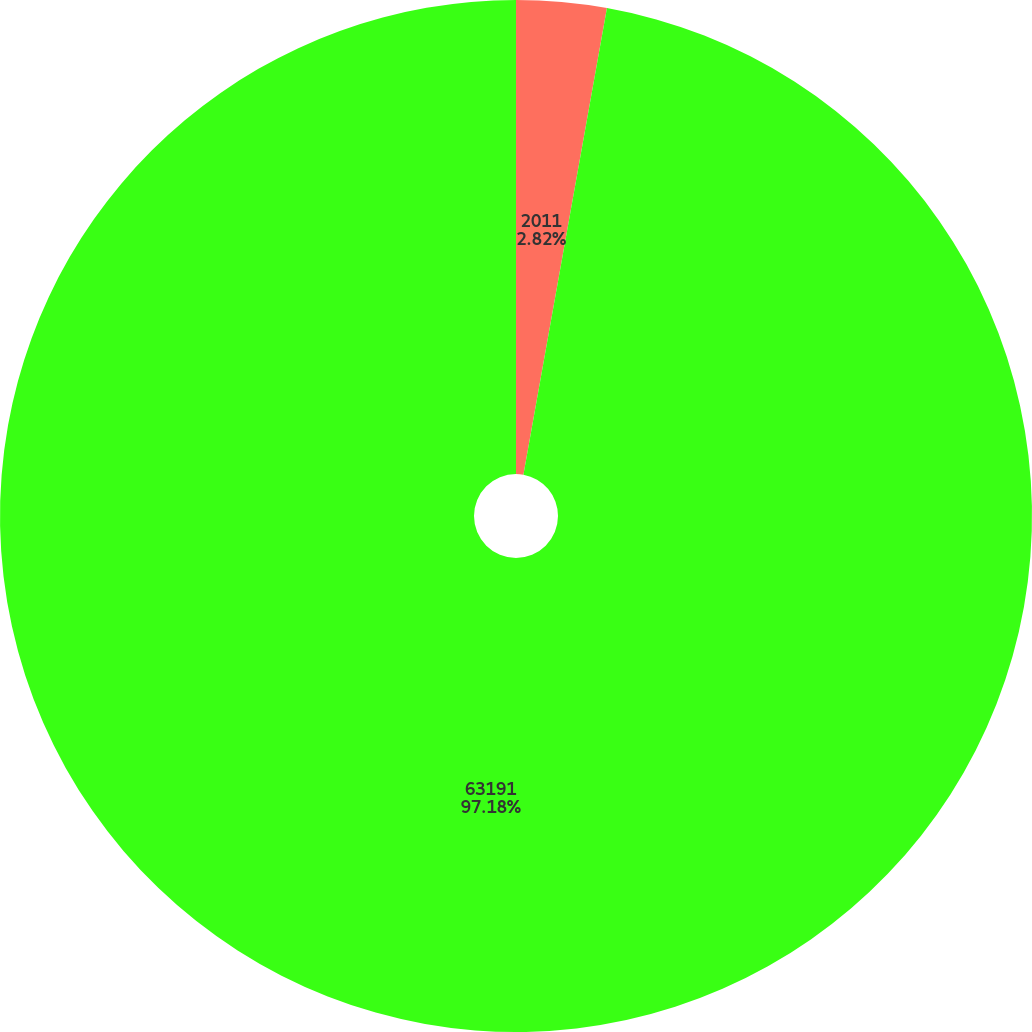Convert chart. <chart><loc_0><loc_0><loc_500><loc_500><pie_chart><fcel>2011<fcel>63191<nl><fcel>2.82%<fcel>97.18%<nl></chart> 